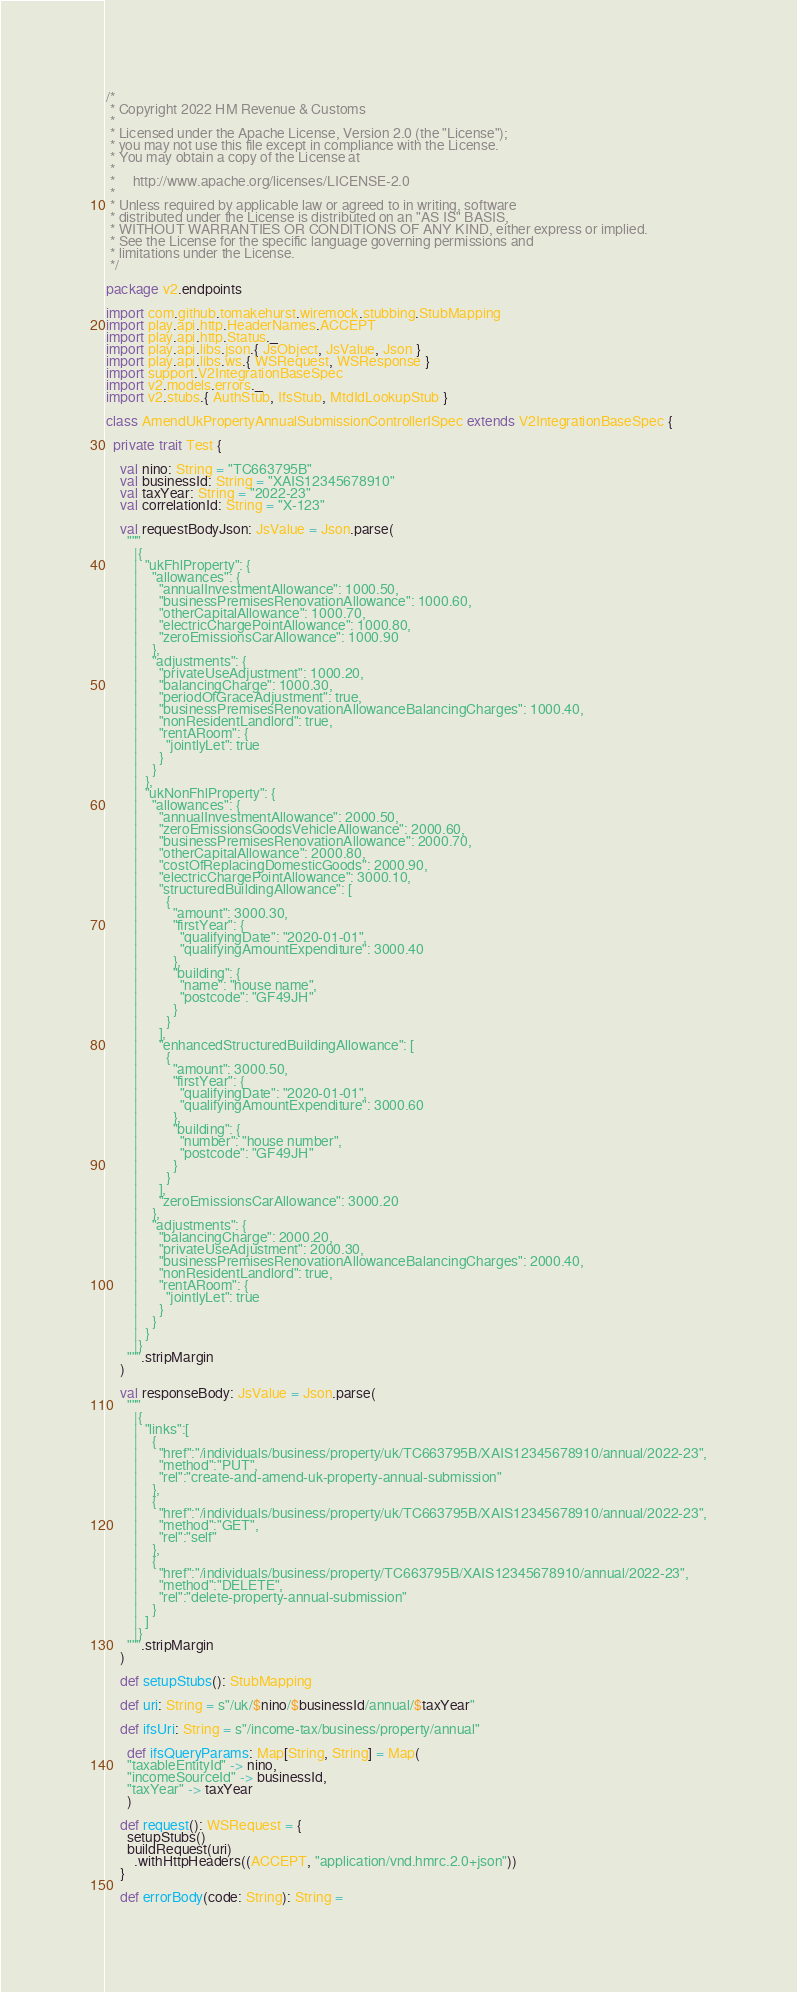<code> <loc_0><loc_0><loc_500><loc_500><_Scala_>/*
 * Copyright 2022 HM Revenue & Customs
 *
 * Licensed under the Apache License, Version 2.0 (the "License");
 * you may not use this file except in compliance with the License.
 * You may obtain a copy of the License at
 *
 *     http://www.apache.org/licenses/LICENSE-2.0
 *
 * Unless required by applicable law or agreed to in writing, software
 * distributed under the License is distributed on an "AS IS" BASIS,
 * WITHOUT WARRANTIES OR CONDITIONS OF ANY KIND, either express or implied.
 * See the License for the specific language governing permissions and
 * limitations under the License.
 */

package v2.endpoints

import com.github.tomakehurst.wiremock.stubbing.StubMapping
import play.api.http.HeaderNames.ACCEPT
import play.api.http.Status._
import play.api.libs.json.{ JsObject, JsValue, Json }
import play.api.libs.ws.{ WSRequest, WSResponse }
import support.V2IntegrationBaseSpec
import v2.models.errors._
import v2.stubs.{ AuthStub, IfsStub, MtdIdLookupStub }

class AmendUkPropertyAnnualSubmissionControllerISpec extends V2IntegrationBaseSpec {

  private trait Test {

    val nino: String = "TC663795B"
    val businessId: String = "XAIS12345678910"
    val taxYear: String = "2022-23"
    val correlationId: String = "X-123"

    val requestBodyJson: JsValue = Json.parse(
      """
        |{
        |  "ukFhlProperty": {
        |    "allowances": {
        |      "annualInvestmentAllowance": 1000.50,
        |      "businessPremisesRenovationAllowance": 1000.60,
        |      "otherCapitalAllowance": 1000.70,
        |      "electricChargePointAllowance": 1000.80,
        |      "zeroEmissionsCarAllowance": 1000.90
        |    },
        |    "adjustments": {
        |      "privateUseAdjustment": 1000.20,
        |      "balancingCharge": 1000.30,
        |      "periodOfGraceAdjustment": true,
        |      "businessPremisesRenovationAllowanceBalancingCharges": 1000.40,
        |      "nonResidentLandlord": true,
        |      "rentARoom": {
        |        "jointlyLet": true
        |      }
        |    }
        |  },
        |  "ukNonFhlProperty": {
        |    "allowances": {
        |      "annualInvestmentAllowance": 2000.50,
        |      "zeroEmissionsGoodsVehicleAllowance": 2000.60,
        |      "businessPremisesRenovationAllowance": 2000.70,
        |      "otherCapitalAllowance": 2000.80,
        |      "costOfReplacingDomesticGoods": 2000.90,
        |      "electricChargePointAllowance": 3000.10,
        |      "structuredBuildingAllowance": [
        |        {
        |          "amount": 3000.30,
        |          "firstYear": {
        |            "qualifyingDate": "2020-01-01",
        |            "qualifyingAmountExpenditure": 3000.40
        |          },
        |          "building": {
        |            "name": "house name",
        |            "postcode": "GF49JH"
        |          }
        |        }
        |      ],
        |      "enhancedStructuredBuildingAllowance": [
        |        {
        |          "amount": 3000.50,
        |          "firstYear": {
        |            "qualifyingDate": "2020-01-01",
        |            "qualifyingAmountExpenditure": 3000.60
        |          },
        |          "building": {
        |            "number": "house number",
        |            "postcode": "GF49JH"
        |          }
        |        }
        |      ],
        |      "zeroEmissionsCarAllowance": 3000.20
        |    },
        |    "adjustments": {
        |      "balancingCharge": 2000.20,
        |      "privateUseAdjustment": 2000.30,
        |      "businessPremisesRenovationAllowanceBalancingCharges": 2000.40,
        |      "nonResidentLandlord": true,
        |      "rentARoom": {
        |        "jointlyLet": true
        |      }
        |    }
        |  }
        |}
      """.stripMargin
    )

    val responseBody: JsValue = Json.parse(
      """
        |{
        |  "links":[
        |    {
        |      "href":"/individuals/business/property/uk/TC663795B/XAIS12345678910/annual/2022-23",
        |      "method":"PUT",
        |      "rel":"create-and-amend-uk-property-annual-submission"
        |    },
        |    {
        |      "href":"/individuals/business/property/uk/TC663795B/XAIS12345678910/annual/2022-23",
        |      "method":"GET",
        |      "rel":"self"
        |    },
        |    {
        |      "href":"/individuals/business/property/TC663795B/XAIS12345678910/annual/2022-23",
        |      "method":"DELETE",
        |      "rel":"delete-property-annual-submission"
        |    }
        |  ]
        |}
      """.stripMargin
    )

    def setupStubs(): StubMapping

    def uri: String = s"/uk/$nino/$businessId/annual/$taxYear"

    def ifsUri: String = s"/income-tax/business/property/annual"

      def ifsQueryParams: Map[String, String] = Map(
      "taxableEntityId" -> nino,
      "incomeSourceId" -> businessId,
      "taxYear" -> taxYear
      )

    def request(): WSRequest = {
      setupStubs()
      buildRequest(uri)
        .withHttpHeaders((ACCEPT, "application/vnd.hmrc.2.0+json"))
    }

    def errorBody(code: String): String =</code> 